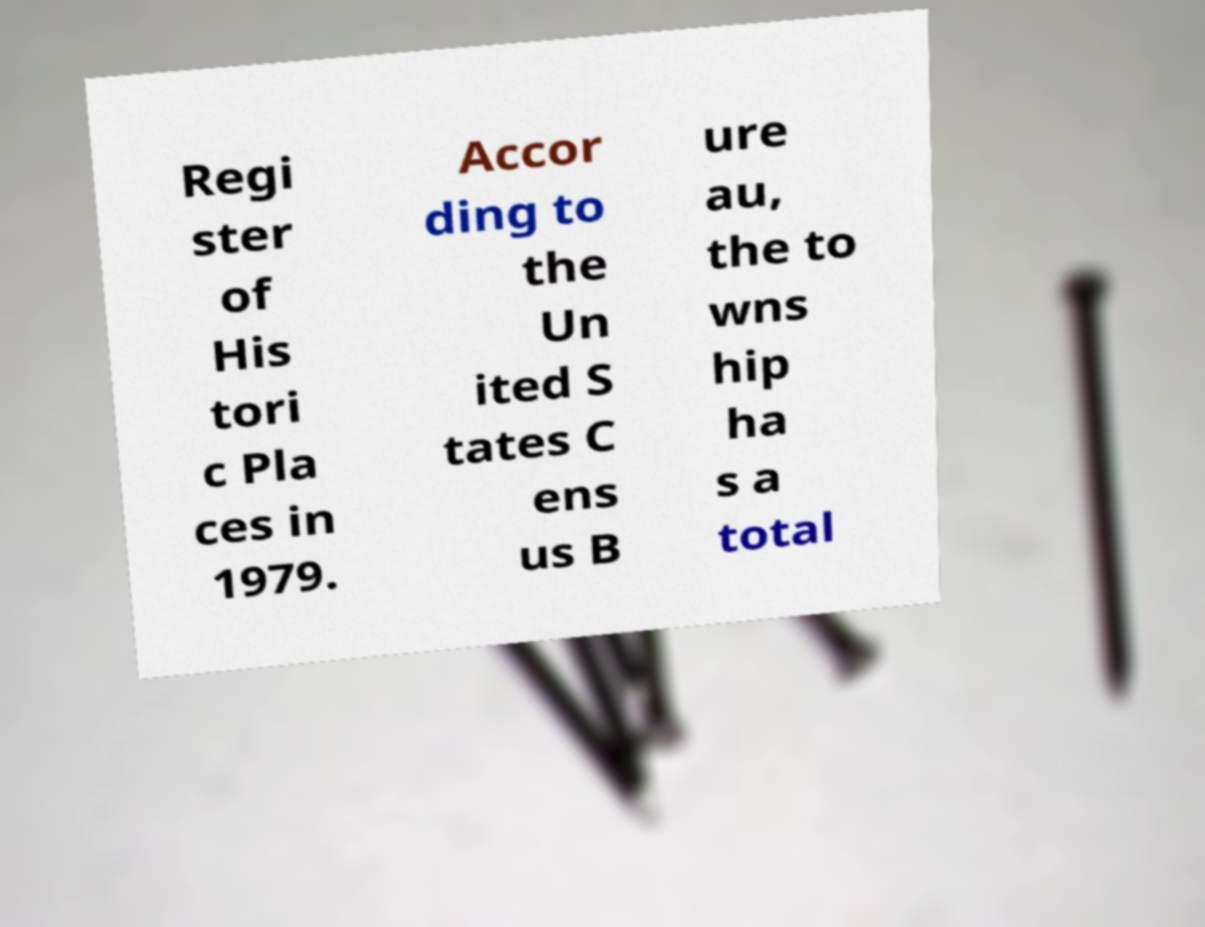Could you extract and type out the text from this image? Regi ster of His tori c Pla ces in 1979. Accor ding to the Un ited S tates C ens us B ure au, the to wns hip ha s a total 